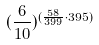Convert formula to latex. <formula><loc_0><loc_0><loc_500><loc_500>( \frac { 6 } { 1 0 } ) ^ { ( \frac { 5 8 } { 3 9 9 } \cdot 3 9 5 ) }</formula> 